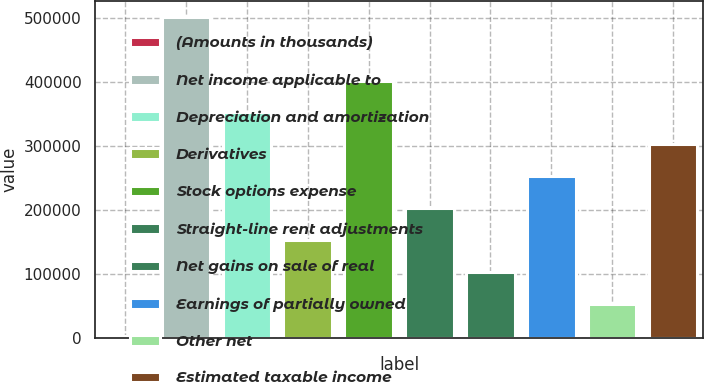Convert chart to OTSL. <chart><loc_0><loc_0><loc_500><loc_500><bar_chart><fcel>(Amounts in thousands)<fcel>Net income applicable to<fcel>Depreciation and amortization<fcel>Derivatives<fcel>Stock options expense<fcel>Straight-line rent adjustments<fcel>Net gains on sale of real<fcel>Earnings of partially owned<fcel>Other net<fcel>Estimated taxable income<nl><fcel>2006<fcel>502629<fcel>352442<fcel>152193<fcel>402504<fcel>202255<fcel>102131<fcel>252318<fcel>52068.3<fcel>302380<nl></chart> 